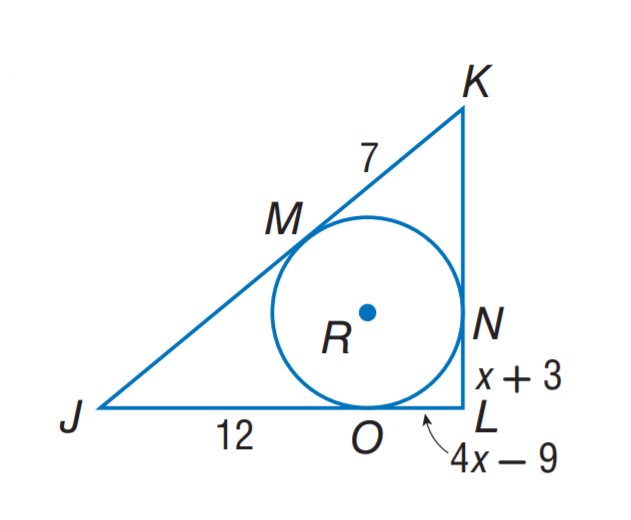Question: Triangle J K L is circumscribed about \odot R. Find the perimeter of \triangle J K L.
Choices:
A. 38
B. 52
C. 54
D. 74
Answer with the letter. Answer: B Question: Triangle J K L is circumscribed about \odot R. Find x.
Choices:
A. 3
B. 4
C. 7
D. 9
Answer with the letter. Answer: B 